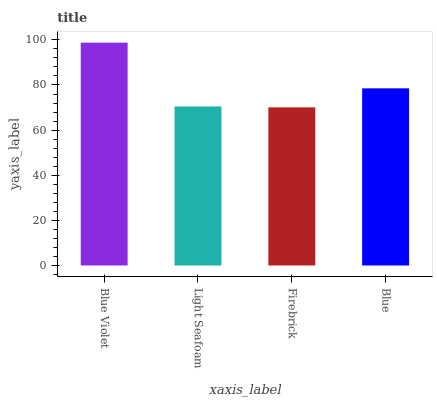Is Firebrick the minimum?
Answer yes or no. Yes. Is Blue Violet the maximum?
Answer yes or no. Yes. Is Light Seafoam the minimum?
Answer yes or no. No. Is Light Seafoam the maximum?
Answer yes or no. No. Is Blue Violet greater than Light Seafoam?
Answer yes or no. Yes. Is Light Seafoam less than Blue Violet?
Answer yes or no. Yes. Is Light Seafoam greater than Blue Violet?
Answer yes or no. No. Is Blue Violet less than Light Seafoam?
Answer yes or no. No. Is Blue the high median?
Answer yes or no. Yes. Is Light Seafoam the low median?
Answer yes or no. Yes. Is Firebrick the high median?
Answer yes or no. No. Is Blue the low median?
Answer yes or no. No. 